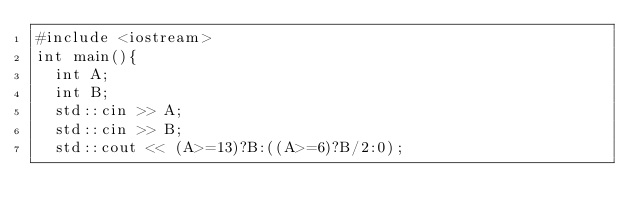<code> <loc_0><loc_0><loc_500><loc_500><_C++_>#include <iostream>
int main(){
  int A;
  int B;
  std::cin >> A;
  std::cin >> B;
  std::cout << (A>=13)?B:((A>=6)?B/2:0);</code> 